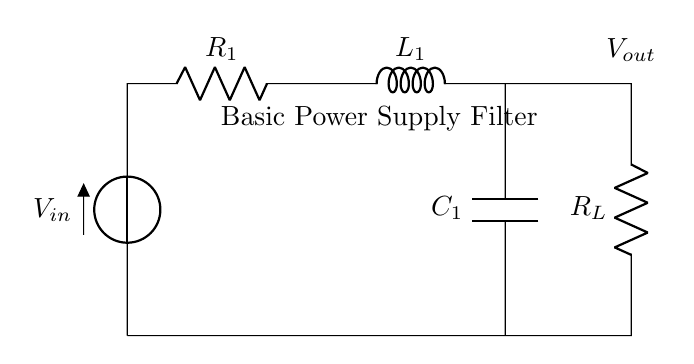What components are present in this circuit? The circuit contains a voltage source (V), two resistors (R1 and RL), one inductor (L1), and one capacitor (C1). These components are explicitly labeled in the diagram.
Answer: Voltage source, two resistors, one inductor, one capacitor What is the purpose of the capacitor in this circuit? The capacitor smooths the output voltage by filtering out fluctuations, thus providing a more stable DC voltage supply. This is a common function for capacitors in power supply circuits.
Answer: To smooth the output voltage What is the voltage at the output node (Vout)? The output voltage is indicated after the resistors and inductor, dependent on the input voltage and the circuit elements. In this case, it is commonly less than or equal to the input voltage if properly configured.
Answer: Less than or equal to V_in How are the resistors connected in this circuit? R1 is in series with the voltage source and inductor, while RL is in series with the output path. Both resistors influence the current flow and voltage drop in their respective sections of the circuit.
Answer: R1 is in series with L1; RL is in series with C1 What type of filter is produced by this circuit? The circuit functions as a low-pass filter, allowing low-frequency signals to pass while attenuating higher-frequency components. This is typical for power supply filter circuits using inductors and capacitors.
Answer: Low-pass filter What is the effect of increasing the inductance value of L1? Increasing L1's value results in lower ripple and better filtering of AC components in the output, as a larger inductor resists changes in current more effectively. This leads to a smoother output voltage.
Answer: Smoother output voltage 